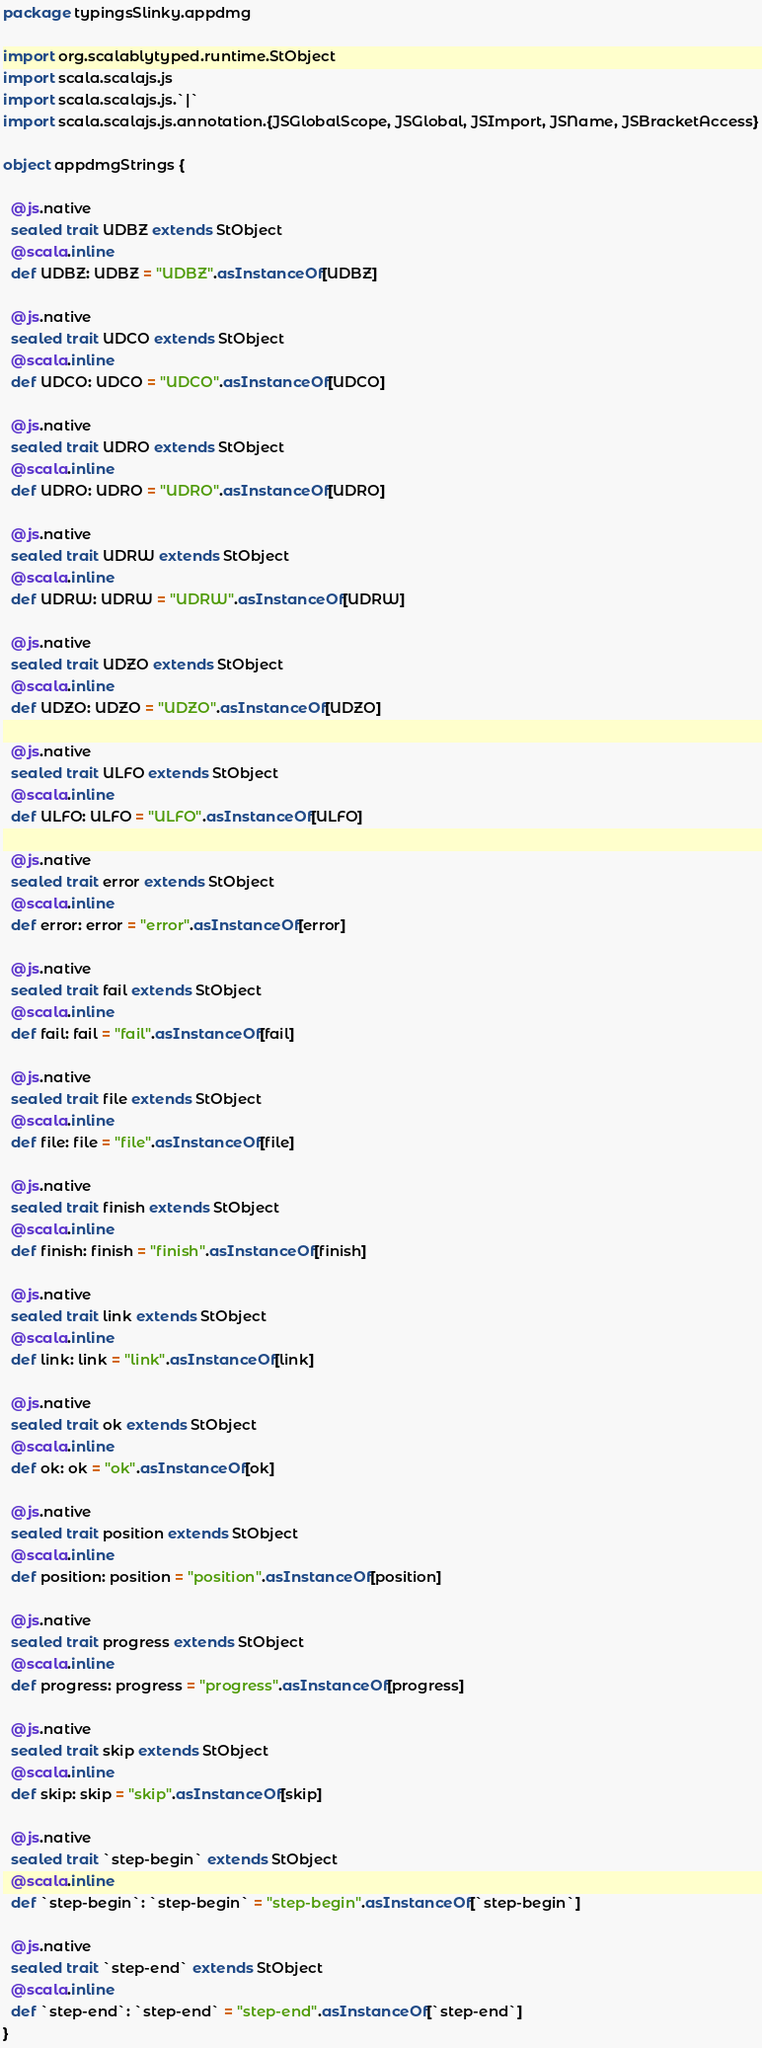Convert code to text. <code><loc_0><loc_0><loc_500><loc_500><_Scala_>package typingsSlinky.appdmg

import org.scalablytyped.runtime.StObject
import scala.scalajs.js
import scala.scalajs.js.`|`
import scala.scalajs.js.annotation.{JSGlobalScope, JSGlobal, JSImport, JSName, JSBracketAccess}

object appdmgStrings {
  
  @js.native
  sealed trait UDBZ extends StObject
  @scala.inline
  def UDBZ: UDBZ = "UDBZ".asInstanceOf[UDBZ]
  
  @js.native
  sealed trait UDCO extends StObject
  @scala.inline
  def UDCO: UDCO = "UDCO".asInstanceOf[UDCO]
  
  @js.native
  sealed trait UDRO extends StObject
  @scala.inline
  def UDRO: UDRO = "UDRO".asInstanceOf[UDRO]
  
  @js.native
  sealed trait UDRW extends StObject
  @scala.inline
  def UDRW: UDRW = "UDRW".asInstanceOf[UDRW]
  
  @js.native
  sealed trait UDZO extends StObject
  @scala.inline
  def UDZO: UDZO = "UDZO".asInstanceOf[UDZO]
  
  @js.native
  sealed trait ULFO extends StObject
  @scala.inline
  def ULFO: ULFO = "ULFO".asInstanceOf[ULFO]
  
  @js.native
  sealed trait error extends StObject
  @scala.inline
  def error: error = "error".asInstanceOf[error]
  
  @js.native
  sealed trait fail extends StObject
  @scala.inline
  def fail: fail = "fail".asInstanceOf[fail]
  
  @js.native
  sealed trait file extends StObject
  @scala.inline
  def file: file = "file".asInstanceOf[file]
  
  @js.native
  sealed trait finish extends StObject
  @scala.inline
  def finish: finish = "finish".asInstanceOf[finish]
  
  @js.native
  sealed trait link extends StObject
  @scala.inline
  def link: link = "link".asInstanceOf[link]
  
  @js.native
  sealed trait ok extends StObject
  @scala.inline
  def ok: ok = "ok".asInstanceOf[ok]
  
  @js.native
  sealed trait position extends StObject
  @scala.inline
  def position: position = "position".asInstanceOf[position]
  
  @js.native
  sealed trait progress extends StObject
  @scala.inline
  def progress: progress = "progress".asInstanceOf[progress]
  
  @js.native
  sealed trait skip extends StObject
  @scala.inline
  def skip: skip = "skip".asInstanceOf[skip]
  
  @js.native
  sealed trait `step-begin` extends StObject
  @scala.inline
  def `step-begin`: `step-begin` = "step-begin".asInstanceOf[`step-begin`]
  
  @js.native
  sealed trait `step-end` extends StObject
  @scala.inline
  def `step-end`: `step-end` = "step-end".asInstanceOf[`step-end`]
}
</code> 